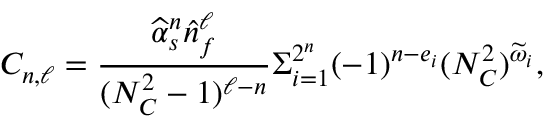<formula> <loc_0><loc_0><loc_500><loc_500>C _ { n , \ell } = { \frac { \widehat { \alpha } _ { s } ^ { n } \widehat { n } _ { f } ^ { \ell } } { ( N _ { C } ^ { 2 } - 1 ) ^ { \ell - n } } } \Sigma _ { i = 1 } ^ { 2 ^ { n } } ( - 1 ) ^ { n - e _ { i } } ( N _ { C } ^ { 2 } ) ^ { \widetilde { \omega } _ { i } } ,</formula> 